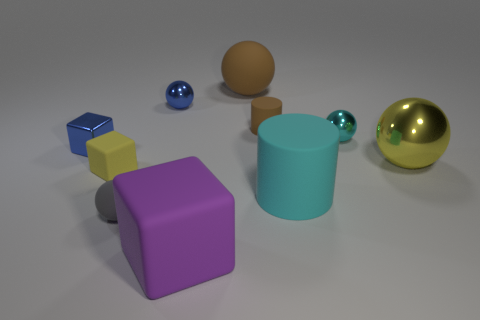What material is the object that is the same color as the large matte cylinder?
Your answer should be very brief. Metal. Is the color of the big shiny object the same as the small rubber cube?
Provide a short and direct response. Yes. There is a cylinder that is the same size as the purple matte thing; what material is it?
Make the answer very short. Rubber. There is a cyan rubber thing that is the same size as the brown rubber ball; what is its shape?
Offer a very short reply. Cylinder. What number of other objects are the same color as the tiny cylinder?
Provide a short and direct response. 1. Does the blue shiny thing left of the small yellow rubber cube have the same shape as the rubber object that is on the left side of the tiny gray thing?
Ensure brevity in your answer.  Yes. What number of objects are objects in front of the large brown rubber sphere or small objects right of the tiny blue shiny block?
Offer a terse response. 9. How many other objects are there of the same material as the large yellow sphere?
Your answer should be compact. 3. Are the tiny blue thing behind the tiny rubber cylinder and the blue cube made of the same material?
Offer a terse response. Yes. Are there more yellow metal things that are behind the large matte ball than yellow metal spheres in front of the yellow sphere?
Make the answer very short. No. 